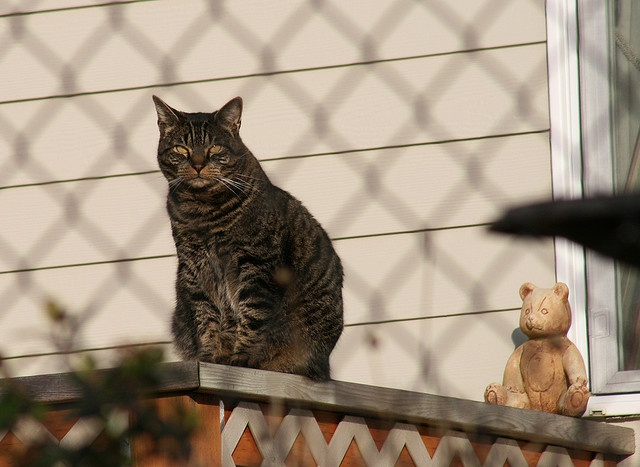Describe the objects in this image and their specific colors. I can see cat in tan, black, maroon, and gray tones and teddy bear in tan, gray, and brown tones in this image. 